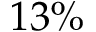Convert formula to latex. <formula><loc_0><loc_0><loc_500><loc_500>1 3 \%</formula> 